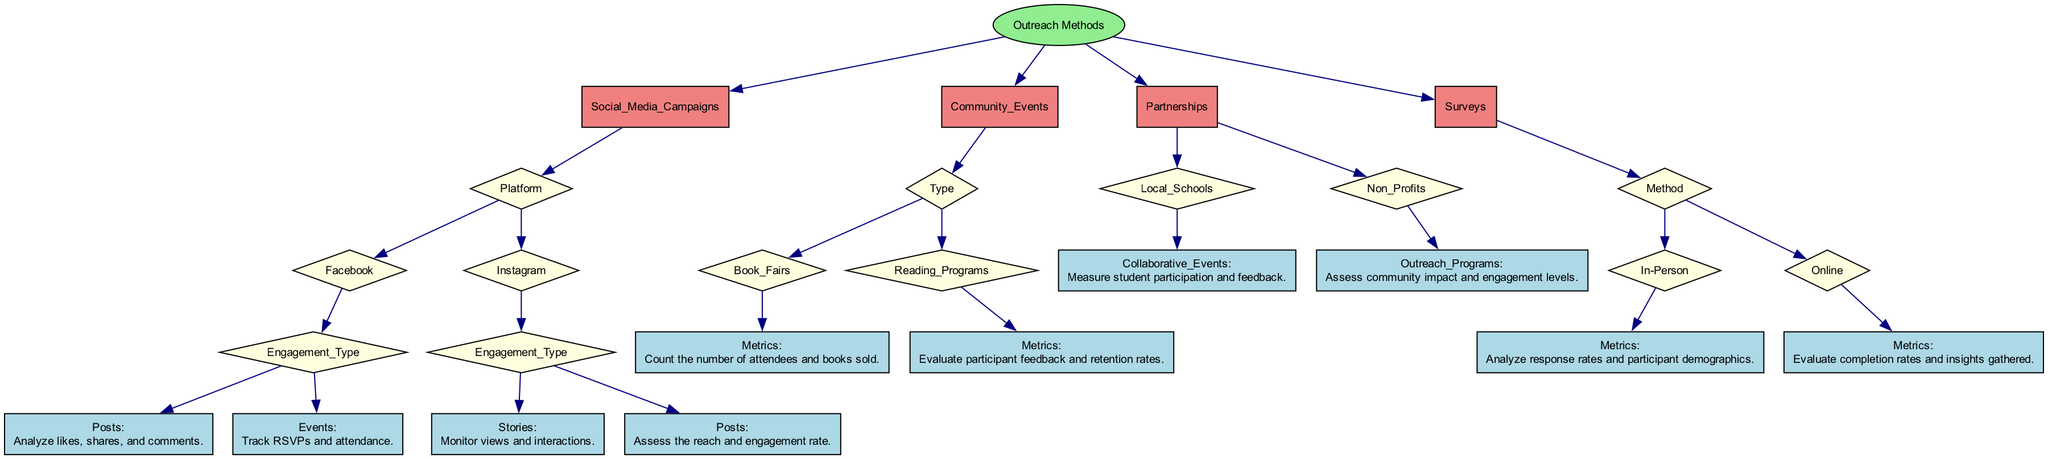What are the main categories of outreach methods? The diagram shows four main categories of outreach methods under the "Outreach Methods" node: Social Media Campaigns, Community Events, Partnerships, and Surveys.
Answer: Social Media Campaigns, Community Events, Partnerships, Surveys How many types of engagement are listed under Facebook? In the diagram, there are two types of engagement listed under Facebook: Posts and Events.
Answer: 2 What metric is used to evaluate reading programs? For Reading Programs, the metric to evaluate them is participant feedback and retention rates, which is shown directly under its category in the outreach method.
Answer: Participant feedback and retention rates Which outreach method includes assessing community impact? The outreach method that includes assessing community impact is Partnerships, specifically under Non-Profits and their Outreach Programs.
Answer: Partnerships What type of methods does the "Surveys" category include? The "Surveys" category includes two methods: In-Person and Online, as detailed within that section of the diagram.
Answer: In-Person, Online What are the engagement types for Instagram? Under Instagram, there are two engagement types: Stories and Posts, as shown in the corresponding section of the diagram.
Answer: Stories, Posts What is the primary metric for Community Events? The primary metric for Community Events is to count the number of attendees and books sold for Book Fairs, as specified in the diagram.
Answer: Count the number of attendees and books sold Why is it essential to monitor interactions on Instagram Stories? Monitoring interactions on Instagram Stories is essential because it provides insights about viewer engagement, which can help tailor future content and outreach strategies effectively.
Answer: Insights about viewer engagement What shape denotes the outreach methods in the diagram? The outreach methods in the diagram are denoted using the shape of a box, which differentiates these nodes from others within the tree structure.
Answer: Box 